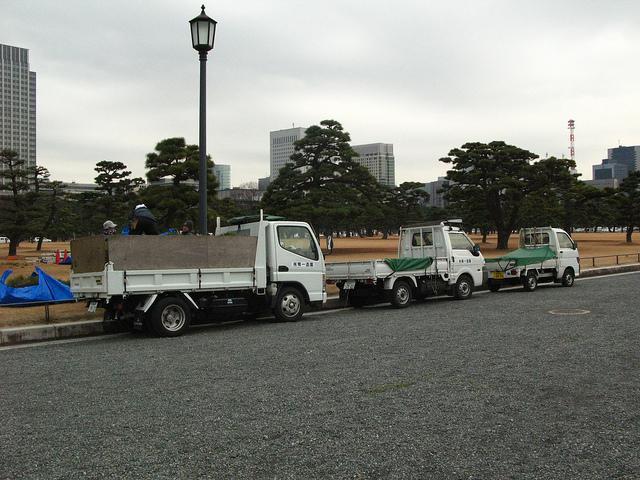How many trucks are in the picture?
Give a very brief answer. 3. 